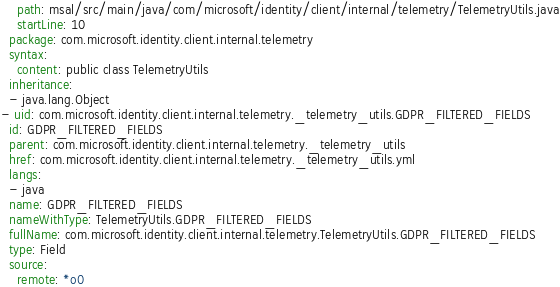<code> <loc_0><loc_0><loc_500><loc_500><_YAML_>    path: msal/src/main/java/com/microsoft/identity/client/internal/telemetry/TelemetryUtils.java
    startLine: 10
  package: com.microsoft.identity.client.internal.telemetry
  syntax:
    content: public class TelemetryUtils
  inheritance:
  - java.lang.Object
- uid: com.microsoft.identity.client.internal.telemetry._telemetry_utils.GDPR_FILTERED_FIELDS
  id: GDPR_FILTERED_FIELDS
  parent: com.microsoft.identity.client.internal.telemetry._telemetry_utils
  href: com.microsoft.identity.client.internal.telemetry._telemetry_utils.yml
  langs:
  - java
  name: GDPR_FILTERED_FIELDS
  nameWithType: TelemetryUtils.GDPR_FILTERED_FIELDS
  fullName: com.microsoft.identity.client.internal.telemetry.TelemetryUtils.GDPR_FILTERED_FIELDS
  type: Field
  source:
    remote: *o0</code> 